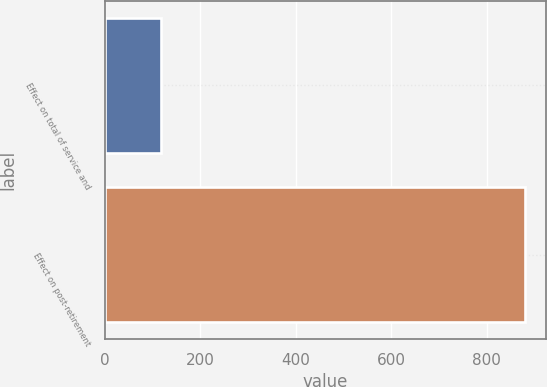Convert chart. <chart><loc_0><loc_0><loc_500><loc_500><bar_chart><fcel>Effect on total of service and<fcel>Effect on post-retirement<nl><fcel>118<fcel>881<nl></chart> 